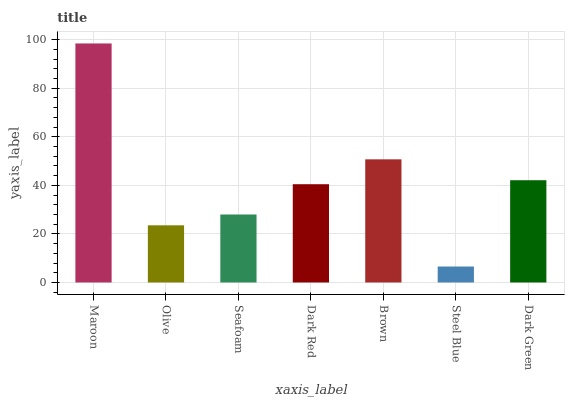Is Steel Blue the minimum?
Answer yes or no. Yes. Is Maroon the maximum?
Answer yes or no. Yes. Is Olive the minimum?
Answer yes or no. No. Is Olive the maximum?
Answer yes or no. No. Is Maroon greater than Olive?
Answer yes or no. Yes. Is Olive less than Maroon?
Answer yes or no. Yes. Is Olive greater than Maroon?
Answer yes or no. No. Is Maroon less than Olive?
Answer yes or no. No. Is Dark Red the high median?
Answer yes or no. Yes. Is Dark Red the low median?
Answer yes or no. Yes. Is Steel Blue the high median?
Answer yes or no. No. Is Olive the low median?
Answer yes or no. No. 